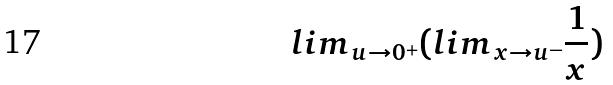<formula> <loc_0><loc_0><loc_500><loc_500>l i m _ { u \rightarrow 0 ^ { + } } ( l i m _ { x \rightarrow u ^ { - } } \frac { 1 } { x } )</formula> 